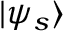Convert formula to latex. <formula><loc_0><loc_0><loc_500><loc_500>| \psi _ { s } \rangle</formula> 